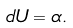<formula> <loc_0><loc_0><loc_500><loc_500>d U = \alpha .</formula> 